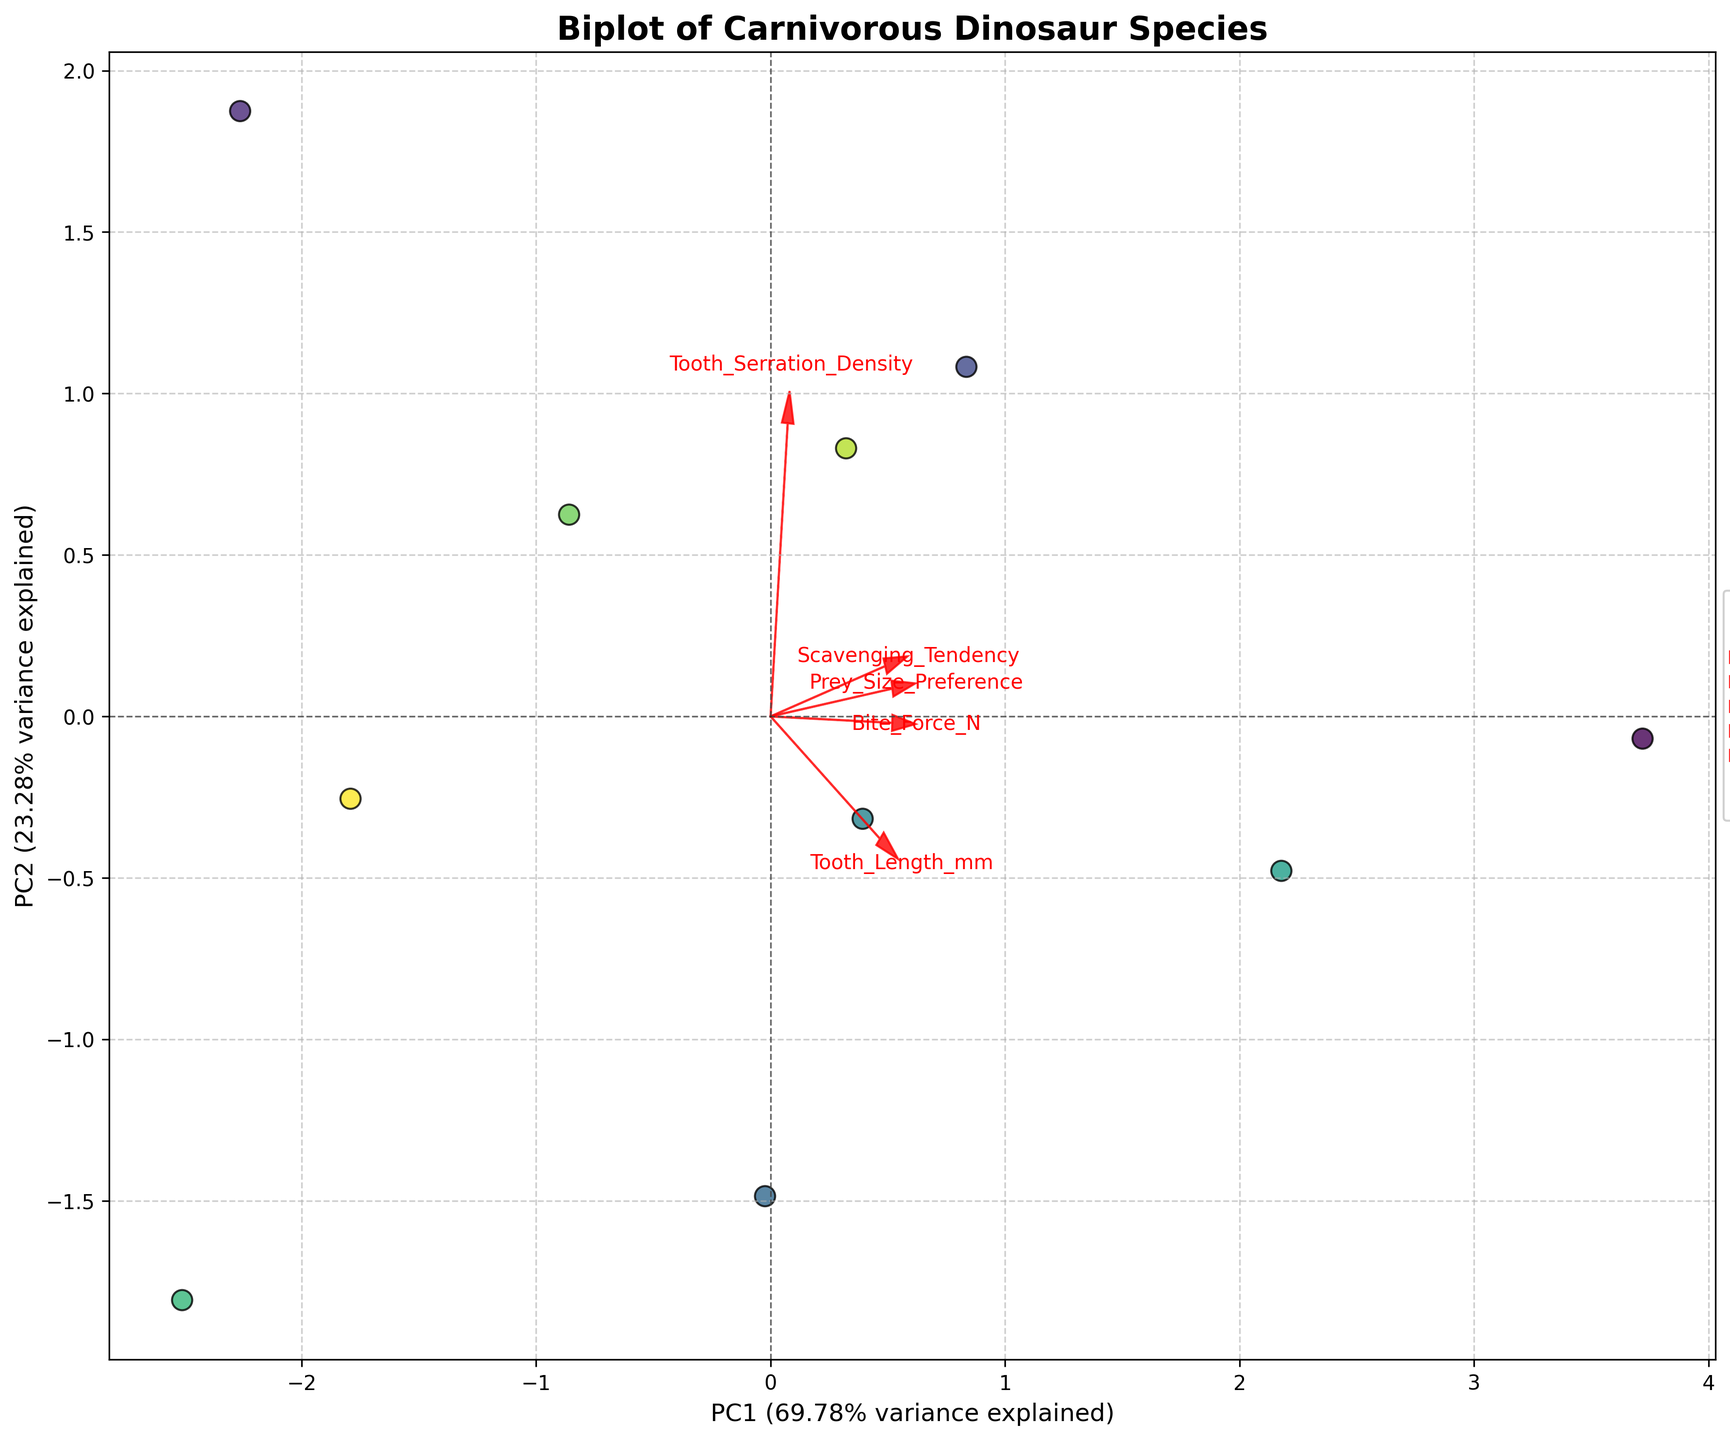What is the title of the figure? The title is usually found at the top of the figure. It gives an overview of what the plot is about. In this case, the title is "Biplot of Carnivorous Dinosaur Species".
Answer: Biplot of Carnivorous Dinosaur Species How many species are represented in this biplot? The legend on the right side of the figure lists all the species represented. By counting the entries, you can determine the number of species.
Answer: 10 Which dinosaur species has the highest value on PC1 (Principal Component 1)? By looking at the x-axis values, you can identify which point is furthest to the right on the PC1 axis.
Answer: Tyrannosaurus rex What percentage of variance is explained by the first principal component (PC1)? This information is usually found in the axis label of PC1. It is a percentage indicating how much of the data's variance is captured by PC1.
Answer: It varies depending on the specific dataset and how it's visualized What is the direction of the arrow for "Bite_Force_N" concerning the PC1 and PC2 axes? The direction of an arrow in a biplot indicates how a particular feature contributes to the principal component axes. For "Bite_Force_N", observe where the arrow points relative to the horizontal and vertical axes.
Answer: Mostly right and slightly up Which feature shows the least contribution to PC2? By analyzing the length and direction of the arrows, you can determine which feature has the least projection on the vertical (PC2) axis. The shorter the arrow in the vertical direction, the lesser the contribution to PC2.
Answer: Bite_Force_N Which species and feature combination is most aligned with the positive direction of PC2? Look for the species close to the top of the biplot and check which arrow is pointing most in the positive vertical direction. This will be the feature aligned with the positive direction of PC2.
Answer: Velociraptor mongoliensis and Tooth_Serration_Density Are the features "Tooth_Length_mm" and "Scavenging_Tendency" positively correlated? In a biplot, if two arrows are pointing in roughly the same direction, it indicates a positive correlation between those features. Observe the directions of the arrows for these two features.
Answer: No Which two species are closest together in the biplot, indicating similar characteristics? Find the pair of points in the plot that are nearest to each other. Closer points indicate species with more similar characteristics.
Answer: Carnotaurus sastrei and Ceratosaurus nasicornis How does prey size preference relate to the other features according to the biplot? You can infer the relationship by examining the direction and length of the "Prey_Size_Preference" arrow relative to other feature arrows. Features pointing in a similar direction have a positive relationship.
Answer: Similar direction with Tooth_Length_mm and Bite_Force_N, positive relationships 